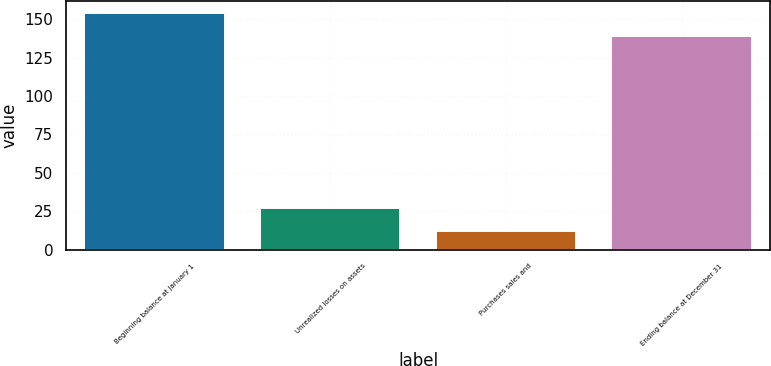Convert chart. <chart><loc_0><loc_0><loc_500><loc_500><bar_chart><fcel>Beginning balance at January 1<fcel>Unrealized losses on assets<fcel>Purchases sales and<fcel>Ending balance at December 31<nl><fcel>154<fcel>27<fcel>12<fcel>139<nl></chart> 